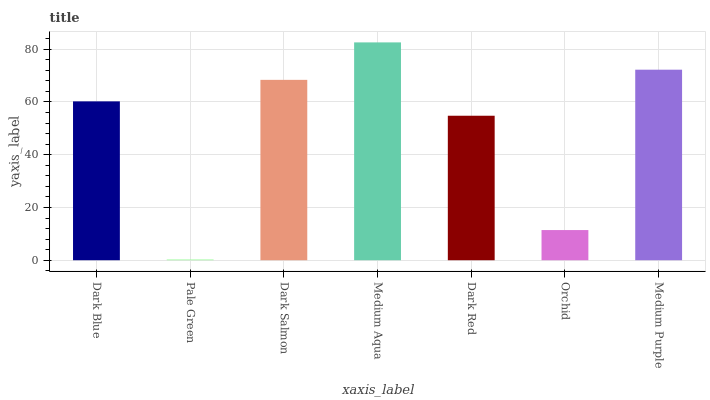Is Pale Green the minimum?
Answer yes or no. Yes. Is Medium Aqua the maximum?
Answer yes or no. Yes. Is Dark Salmon the minimum?
Answer yes or no. No. Is Dark Salmon the maximum?
Answer yes or no. No. Is Dark Salmon greater than Pale Green?
Answer yes or no. Yes. Is Pale Green less than Dark Salmon?
Answer yes or no. Yes. Is Pale Green greater than Dark Salmon?
Answer yes or no. No. Is Dark Salmon less than Pale Green?
Answer yes or no. No. Is Dark Blue the high median?
Answer yes or no. Yes. Is Dark Blue the low median?
Answer yes or no. Yes. Is Orchid the high median?
Answer yes or no. No. Is Dark Red the low median?
Answer yes or no. No. 